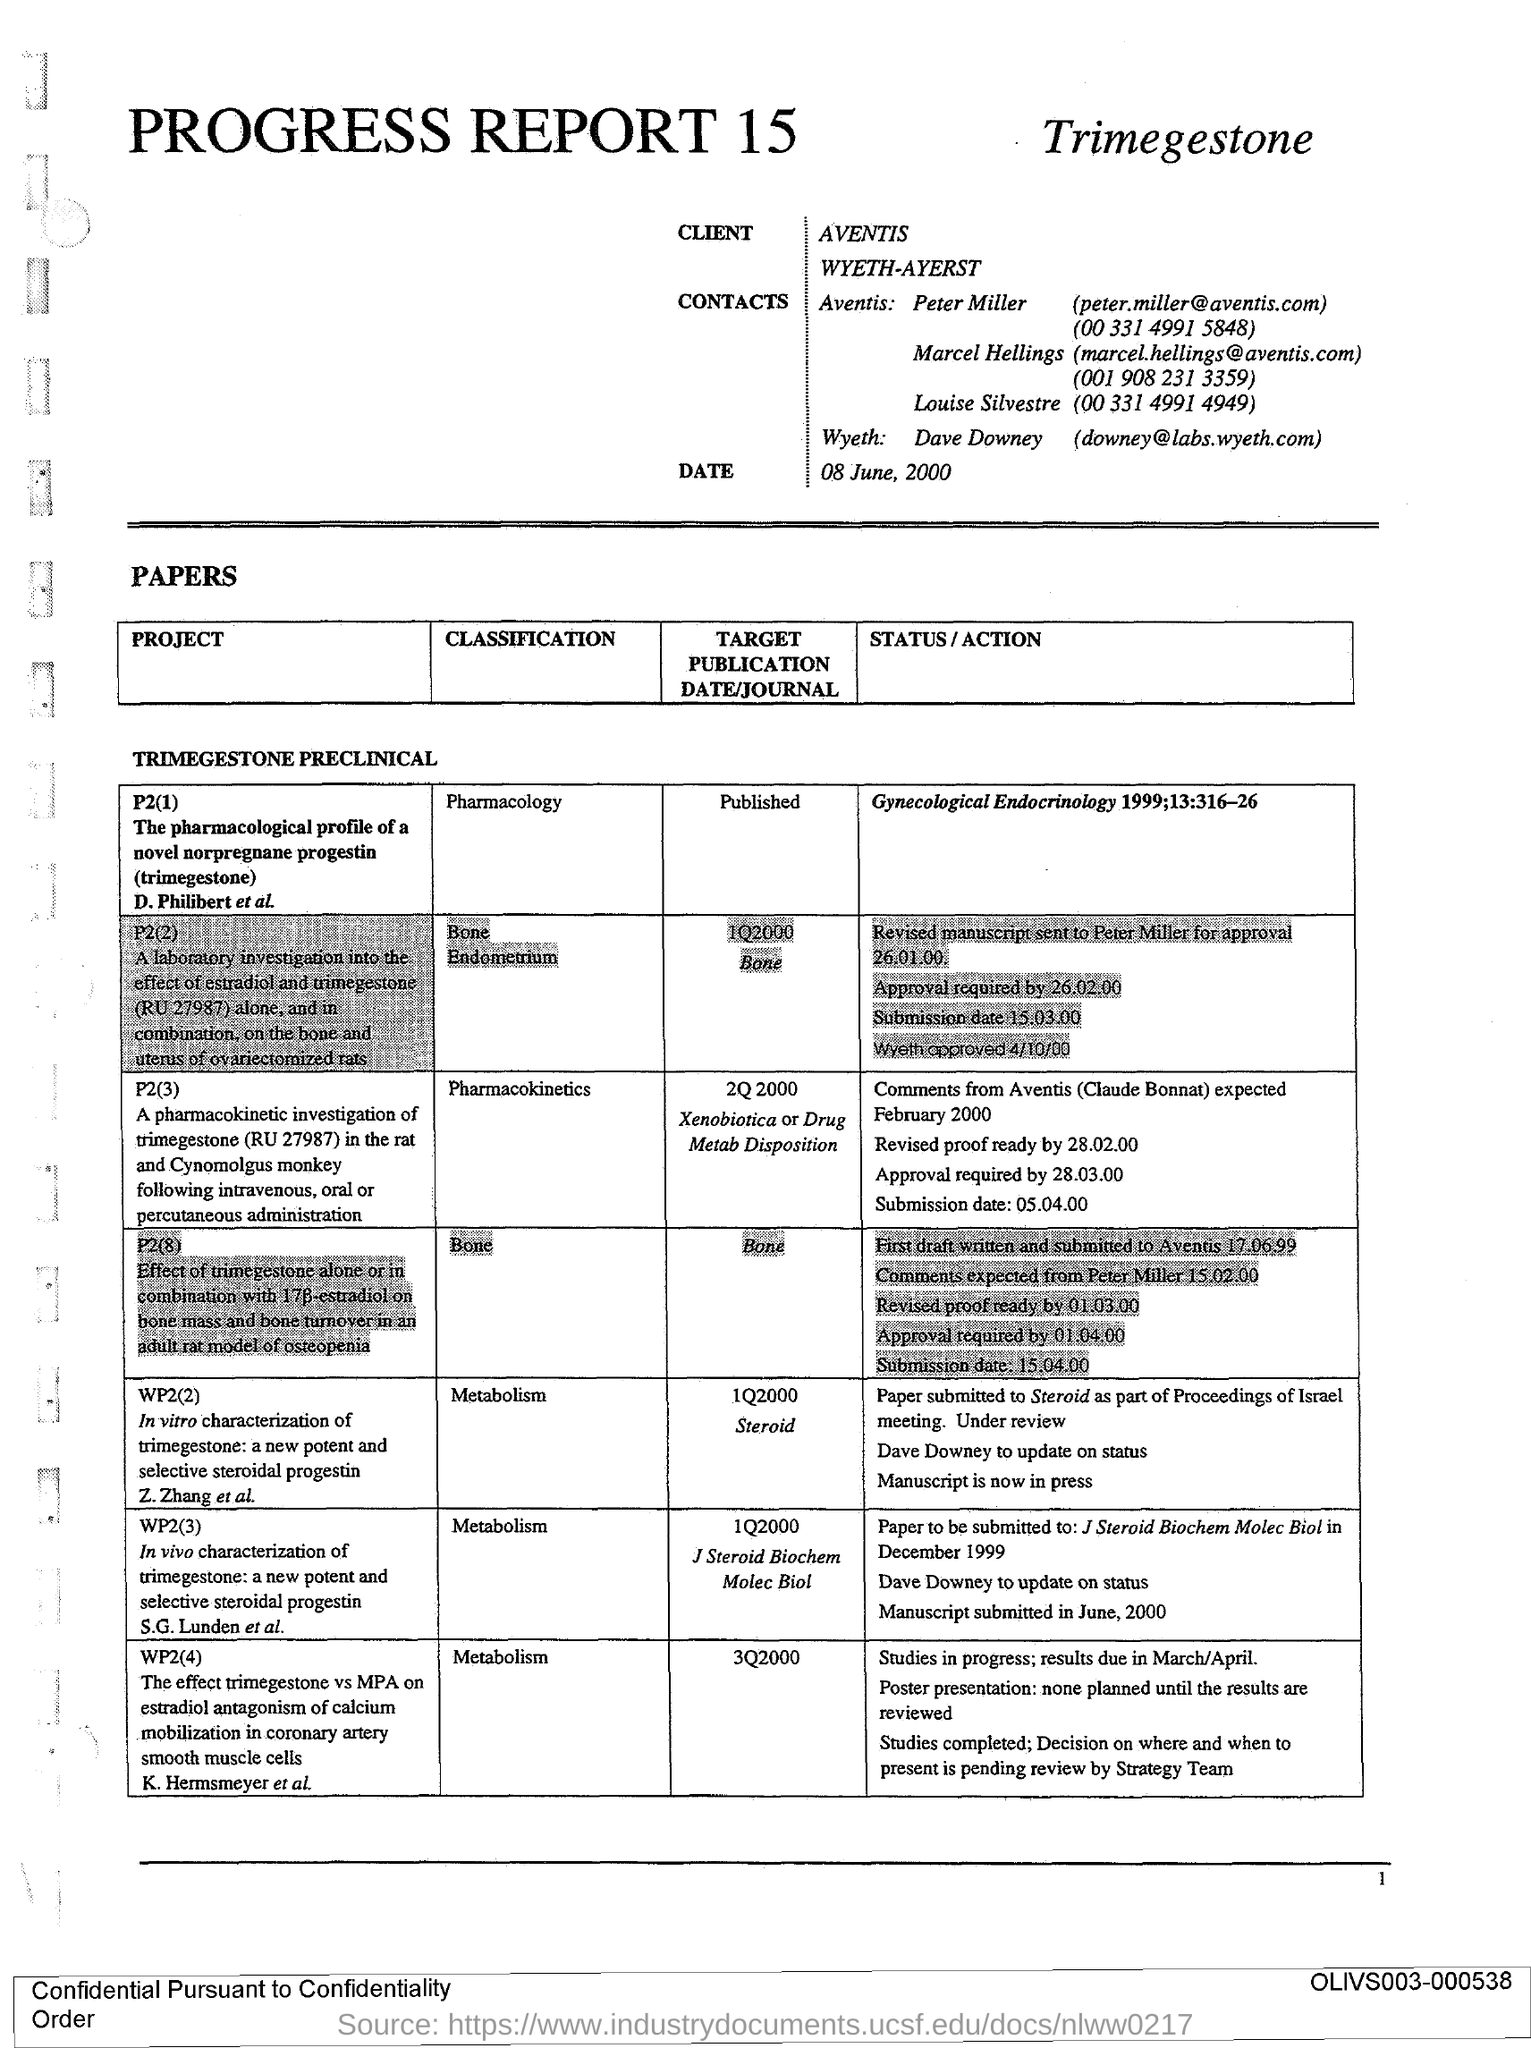Who is the contact of Wyeth?
Keep it short and to the point. Dave Downey. What is the date given?
Make the answer very short. 08 June, 2000. What is Peter Miller's email address?
Offer a very short reply. Peter.miller@aventis.com. What is the telephone number of Louise Silvestre?
Your response must be concise. (00 331 4991 4949). What is the title of project WP2(2)?
Your response must be concise. In vitro characterization of trimegestone: a new potent and selective steroidal progestin. What is the classification of P2 (3)?
Provide a short and direct response. Pharmacokinetics. What is the target submission date/journal for project WP2(4)?
Provide a short and direct response. 3Q2000. 